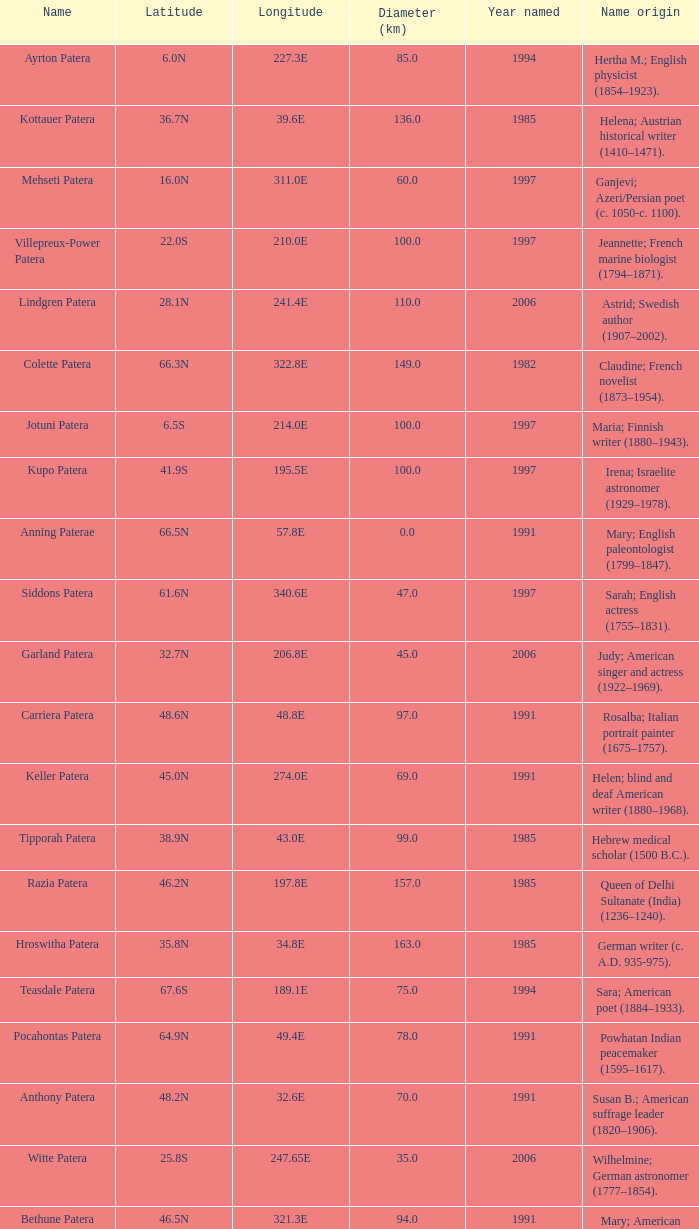What is the origin of the name of Keller Patera?  Helen; blind and deaf American writer (1880–1968). 